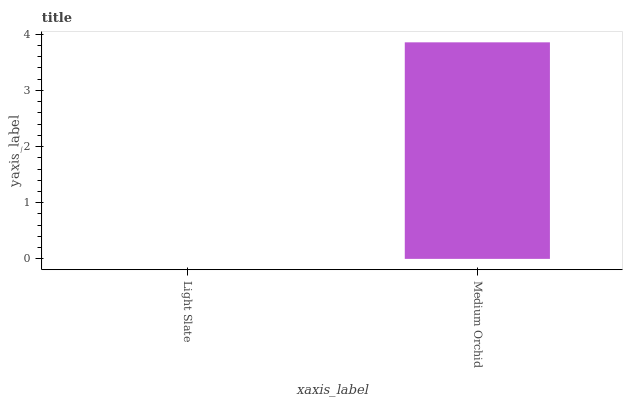Is Medium Orchid the minimum?
Answer yes or no. No. Is Medium Orchid greater than Light Slate?
Answer yes or no. Yes. Is Light Slate less than Medium Orchid?
Answer yes or no. Yes. Is Light Slate greater than Medium Orchid?
Answer yes or no. No. Is Medium Orchid less than Light Slate?
Answer yes or no. No. Is Medium Orchid the high median?
Answer yes or no. Yes. Is Light Slate the low median?
Answer yes or no. Yes. Is Light Slate the high median?
Answer yes or no. No. Is Medium Orchid the low median?
Answer yes or no. No. 